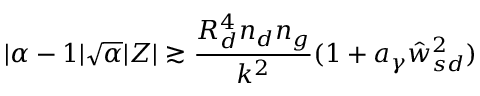Convert formula to latex. <formula><loc_0><loc_0><loc_500><loc_500>| \alpha - 1 | \sqrt { \alpha } | Z | \gtrsim \frac { R _ { d } ^ { 4 } { n _ { d } } n _ { g } } { k ^ { 2 } } ( 1 + a _ { \gamma } \hat { w } _ { s d } ^ { 2 } )</formula> 